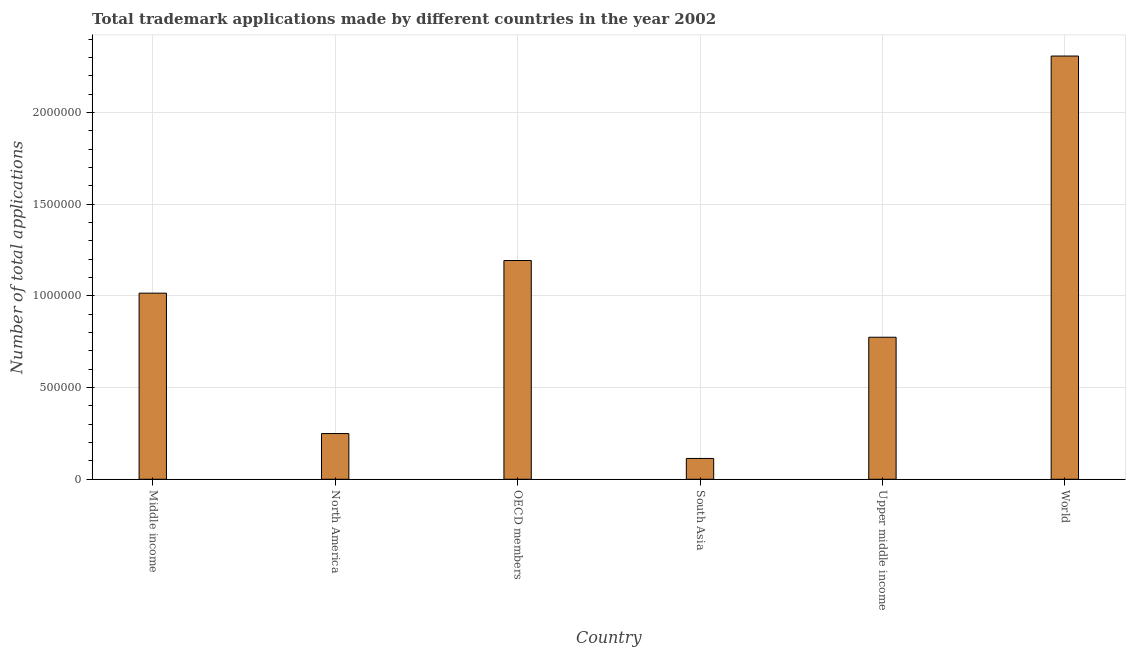Does the graph contain any zero values?
Make the answer very short. No. What is the title of the graph?
Ensure brevity in your answer.  Total trademark applications made by different countries in the year 2002. What is the label or title of the Y-axis?
Give a very brief answer. Number of total applications. What is the number of trademark applications in OECD members?
Provide a succinct answer. 1.19e+06. Across all countries, what is the maximum number of trademark applications?
Provide a succinct answer. 2.31e+06. Across all countries, what is the minimum number of trademark applications?
Your response must be concise. 1.14e+05. In which country was the number of trademark applications minimum?
Your answer should be compact. South Asia. What is the sum of the number of trademark applications?
Give a very brief answer. 5.65e+06. What is the difference between the number of trademark applications in North America and Upper middle income?
Offer a very short reply. -5.25e+05. What is the average number of trademark applications per country?
Make the answer very short. 9.42e+05. What is the median number of trademark applications?
Give a very brief answer. 8.95e+05. In how many countries, is the number of trademark applications greater than 1300000 ?
Offer a terse response. 1. What is the ratio of the number of trademark applications in Middle income to that in World?
Give a very brief answer. 0.44. What is the difference between the highest and the second highest number of trademark applications?
Provide a short and direct response. 1.12e+06. What is the difference between the highest and the lowest number of trademark applications?
Offer a terse response. 2.19e+06. In how many countries, is the number of trademark applications greater than the average number of trademark applications taken over all countries?
Provide a short and direct response. 3. How many countries are there in the graph?
Provide a short and direct response. 6. What is the Number of total applications of Middle income?
Provide a succinct answer. 1.02e+06. What is the Number of total applications in North America?
Offer a terse response. 2.49e+05. What is the Number of total applications in OECD members?
Ensure brevity in your answer.  1.19e+06. What is the Number of total applications of South Asia?
Your answer should be very brief. 1.14e+05. What is the Number of total applications in Upper middle income?
Your answer should be very brief. 7.75e+05. What is the Number of total applications in World?
Give a very brief answer. 2.31e+06. What is the difference between the Number of total applications in Middle income and North America?
Provide a succinct answer. 7.66e+05. What is the difference between the Number of total applications in Middle income and OECD members?
Your answer should be very brief. -1.78e+05. What is the difference between the Number of total applications in Middle income and South Asia?
Your answer should be compact. 9.02e+05. What is the difference between the Number of total applications in Middle income and Upper middle income?
Your answer should be compact. 2.40e+05. What is the difference between the Number of total applications in Middle income and World?
Provide a succinct answer. -1.29e+06. What is the difference between the Number of total applications in North America and OECD members?
Your answer should be compact. -9.44e+05. What is the difference between the Number of total applications in North America and South Asia?
Your answer should be very brief. 1.36e+05. What is the difference between the Number of total applications in North America and Upper middle income?
Your answer should be compact. -5.25e+05. What is the difference between the Number of total applications in North America and World?
Provide a succinct answer. -2.06e+06. What is the difference between the Number of total applications in OECD members and South Asia?
Ensure brevity in your answer.  1.08e+06. What is the difference between the Number of total applications in OECD members and Upper middle income?
Provide a succinct answer. 4.19e+05. What is the difference between the Number of total applications in OECD members and World?
Offer a terse response. -1.12e+06. What is the difference between the Number of total applications in South Asia and Upper middle income?
Make the answer very short. -6.61e+05. What is the difference between the Number of total applications in South Asia and World?
Keep it short and to the point. -2.19e+06. What is the difference between the Number of total applications in Upper middle income and World?
Ensure brevity in your answer.  -1.53e+06. What is the ratio of the Number of total applications in Middle income to that in North America?
Your answer should be very brief. 4.07. What is the ratio of the Number of total applications in Middle income to that in OECD members?
Your response must be concise. 0.85. What is the ratio of the Number of total applications in Middle income to that in South Asia?
Give a very brief answer. 8.94. What is the ratio of the Number of total applications in Middle income to that in Upper middle income?
Provide a short and direct response. 1.31. What is the ratio of the Number of total applications in Middle income to that in World?
Your answer should be compact. 0.44. What is the ratio of the Number of total applications in North America to that in OECD members?
Your response must be concise. 0.21. What is the ratio of the Number of total applications in North America to that in South Asia?
Offer a terse response. 2.2. What is the ratio of the Number of total applications in North America to that in Upper middle income?
Provide a succinct answer. 0.32. What is the ratio of the Number of total applications in North America to that in World?
Offer a terse response. 0.11. What is the ratio of the Number of total applications in OECD members to that in South Asia?
Give a very brief answer. 10.51. What is the ratio of the Number of total applications in OECD members to that in Upper middle income?
Offer a very short reply. 1.54. What is the ratio of the Number of total applications in OECD members to that in World?
Give a very brief answer. 0.52. What is the ratio of the Number of total applications in South Asia to that in Upper middle income?
Offer a terse response. 0.15. What is the ratio of the Number of total applications in South Asia to that in World?
Your answer should be compact. 0.05. What is the ratio of the Number of total applications in Upper middle income to that in World?
Offer a terse response. 0.34. 